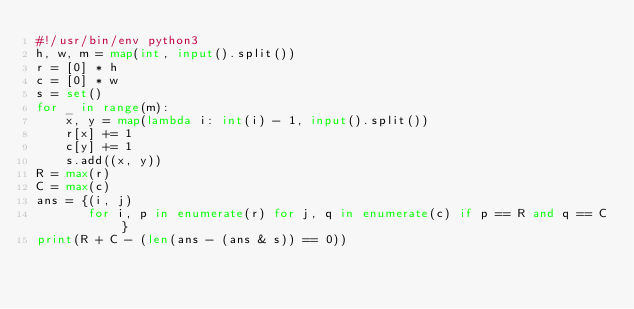Convert code to text. <code><loc_0><loc_0><loc_500><loc_500><_Python_>#!/usr/bin/env python3
h, w, m = map(int, input().split())
r = [0] * h
c = [0] * w
s = set()
for _ in range(m):
    x, y = map(lambda i: int(i) - 1, input().split())
    r[x] += 1
    c[y] += 1
    s.add((x, y))
R = max(r)
C = max(c)
ans = {(i, j)
       for i, p in enumerate(r) for j, q in enumerate(c) if p == R and q == C}
print(R + C - (len(ans - (ans & s)) == 0))
</code> 